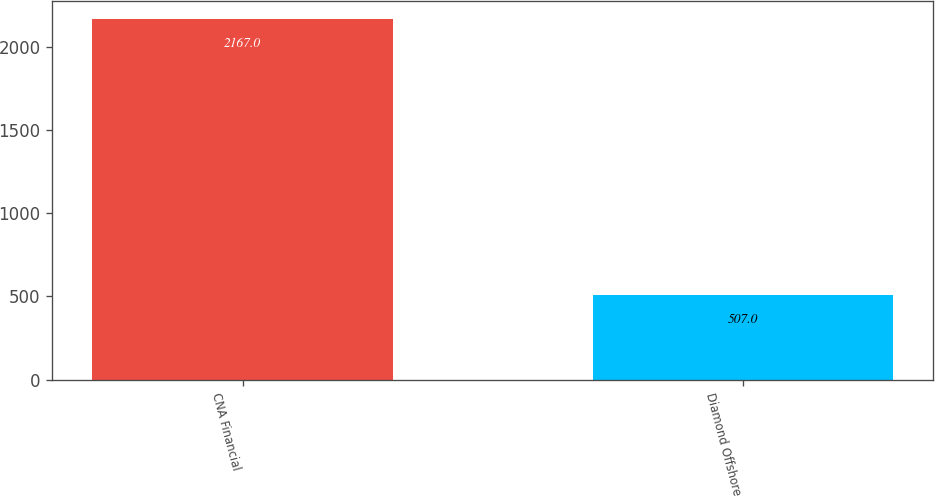<chart> <loc_0><loc_0><loc_500><loc_500><bar_chart><fcel>CNA Financial<fcel>Diamond Offshore<nl><fcel>2167<fcel>507<nl></chart> 